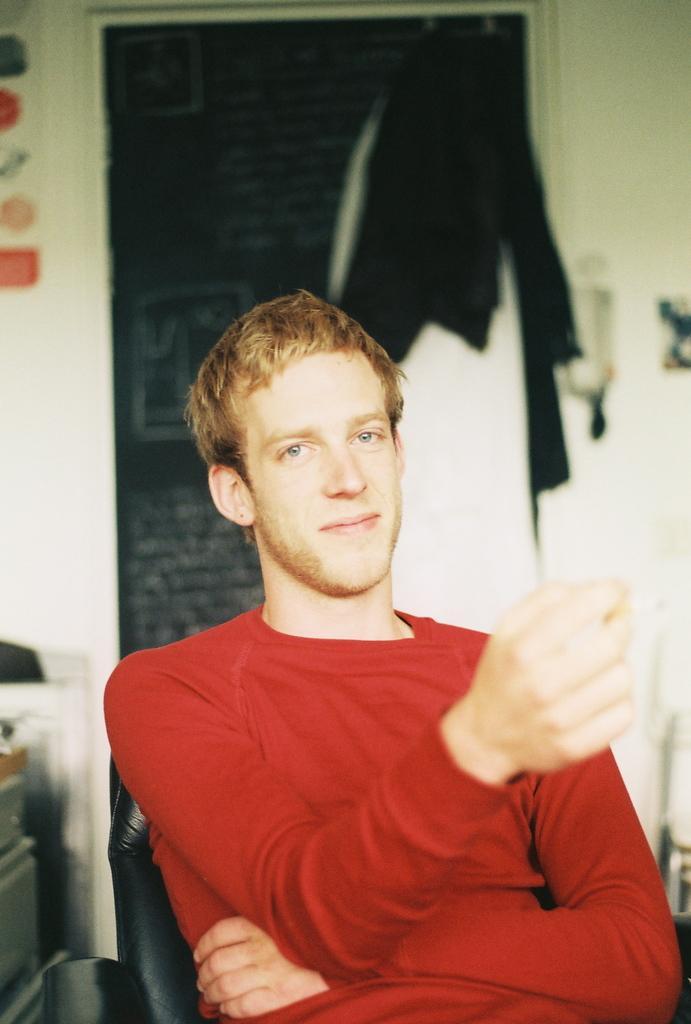Describe this image in one or two sentences. In this image I can see person sitting on the chair and wearing the red color dress. In the back I can see few more clothes and the wall. 